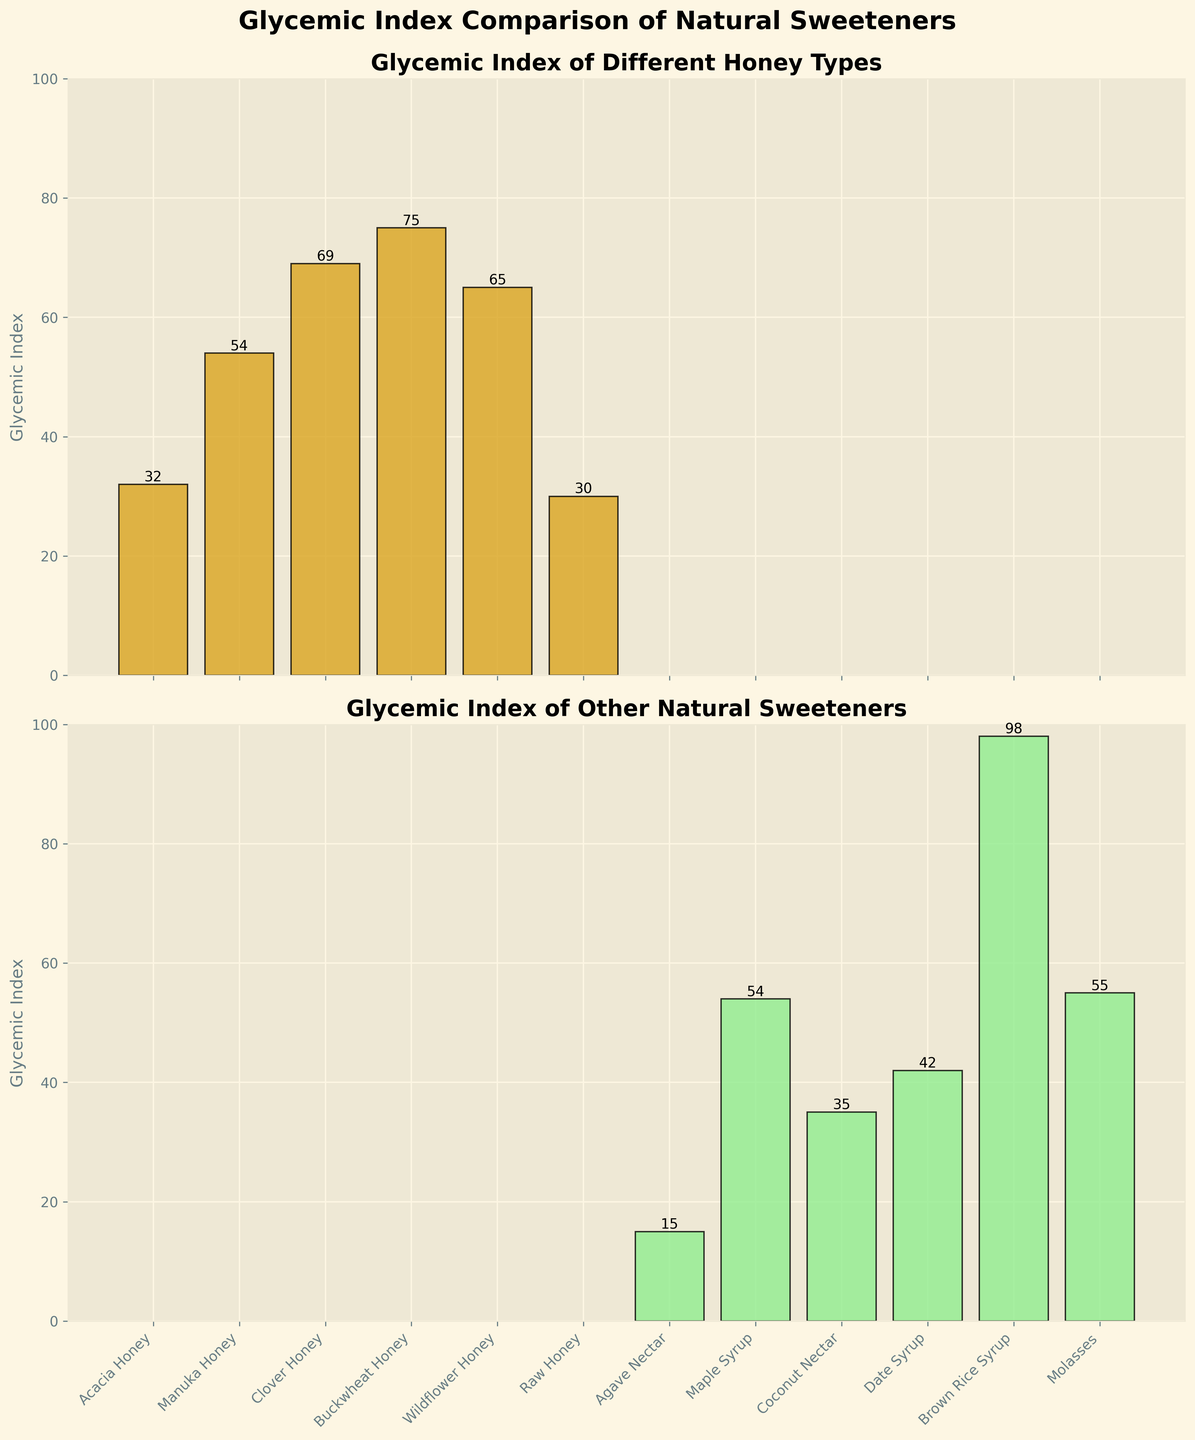what is the glycemic index of Acacia Honey? The glycemic index of Acacia Honey is displayed in the bar corresponding to "Acacia Honey" in the top subplot. The height of this bar indicates its GI value.
Answer: 32 what is the title of the bottom subplot? The title of the bottom subplot is written at the top of the second panel, and it provides context for the bars shown beneath it.
Answer: Glycemic Index of Other Natural Sweeteners which sweetener has the highest glycemic index value? By comparing the height of all bars in both subplots, we find that the bar representing "Brown Rice Syrup" is the tallest.
Answer: Brown Rice Syrup Is Raw Honey's glycemic index higher than Coconut Nectar's? The glycemic index of Raw Honey is 30, and the glycemic index of Coconut Nectar is 35. Since 30 is less than 35, Raw Honey has a lower glycemic index.
Answer: No how many different types of honey are compared in the figure? Count the number of bars in the top subplot, which shows different types of honey.
Answer: 6 How does Buckwheat Honey's glycemic index compare to Date Syrup's? Buckwheat Honey has a glycemic index of 75, whereas Date Syrup has a glycemic index of 42, as indicated by the bar heights.
Answer: Buckwheat Honey's glycemic index is higher what is the average glycemic index of the honey types? Sum the glycemic index values of all the honey types (30 + 32 + 54 + 65 + 69 + 75) and divide by the number of honey types (6). (30 + 32 + 54 + 65 + 69 + 75) / 6 = 53.17
Answer: 53.17 Which sweeteners have a glycemic index above 50? Look at both subplots and list sweeteners with bars higher than 50. These are Brown Rice Syrup, Molasses, Buckwheat Honey, Clover Honey, Wildflower Honey, and Manuka Honey.
Answer: Brown Rice Syrup, Molasses, Buckwheat Honey, Clover Honey, Wildflower Honey, Manuka Honey what is the difference in glycemic index between the highest and lowest sweeteners? Identify the highest glycemic index (Brown Rice Syrup, 98) and the lowest glycemic index (Agave Nectar, 15) sweeteners, then subtract the lowest from the highest. 98 - 15 = 83
Answer: 83 What unique feature is used to color the bars for honey types? The bars representing honey types in the top subplot are colored differently from other natural sweeteners, using a goldenrod color.
Answer: goldenrod 